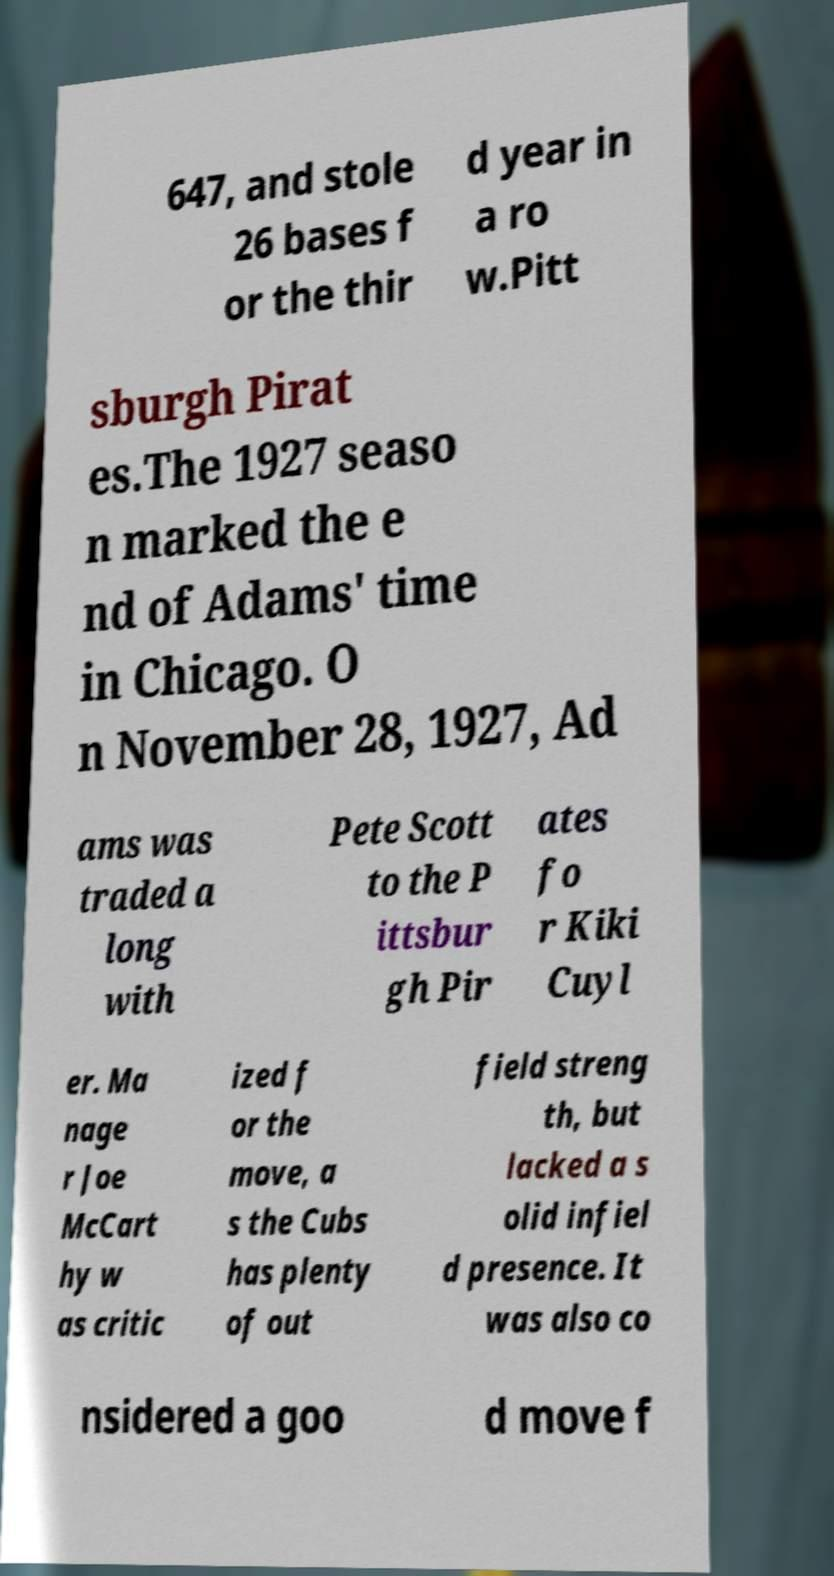Can you accurately transcribe the text from the provided image for me? 647, and stole 26 bases f or the thir d year in a ro w.Pitt sburgh Pirat es.The 1927 seaso n marked the e nd of Adams' time in Chicago. O n November 28, 1927, Ad ams was traded a long with Pete Scott to the P ittsbur gh Pir ates fo r Kiki Cuyl er. Ma nage r Joe McCart hy w as critic ized f or the move, a s the Cubs has plenty of out field streng th, but lacked a s olid infiel d presence. It was also co nsidered a goo d move f 